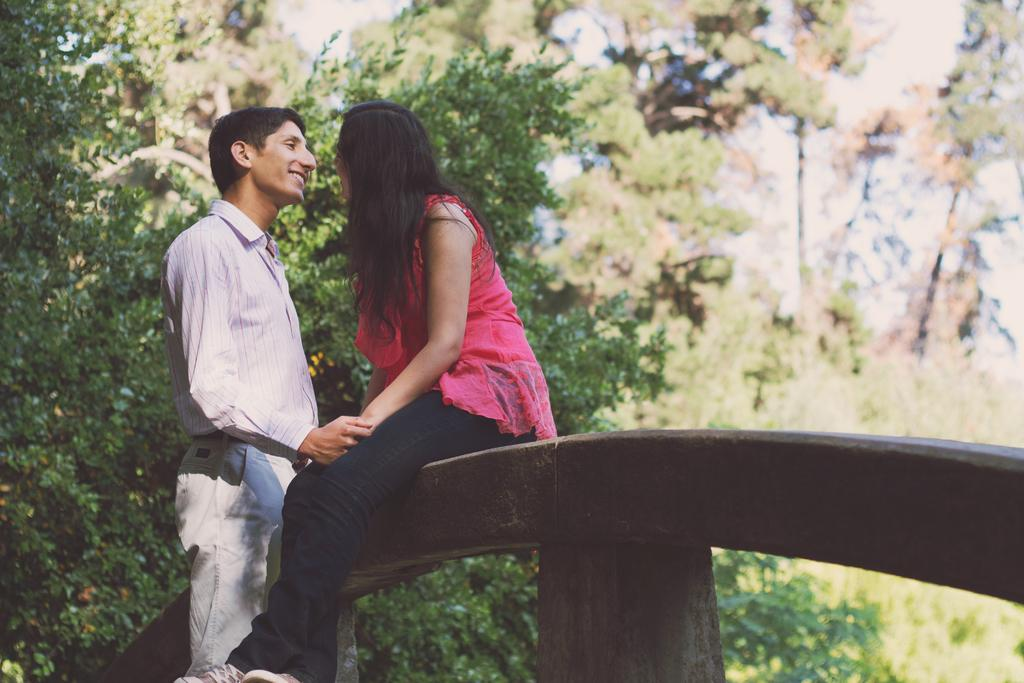How many people are in the image? There are two persons in the image. What is the woman sitting on in the image? The woman is sitting on a wooden block. What is the woman wearing in the image? The woman is wearing a pink dress. What is the man wearing in the image? The man is wearing a formal dress. What can be seen in the background of the image? There are many trees in the background of the image. What direction is the sand blowing in the image? There is no sand present in the image, so it is not possible to determine the direction of any blowing sand. 